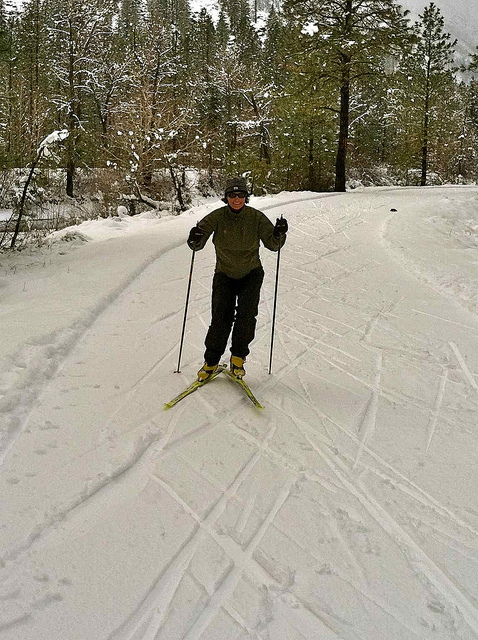<image>Which direction is the sun? It is ambiguous to determine the direction of the sun. It could be east or west. Which direction is the sun? I don't know which direction the sun is. It can be east, north, west or I can't tell from the image. 